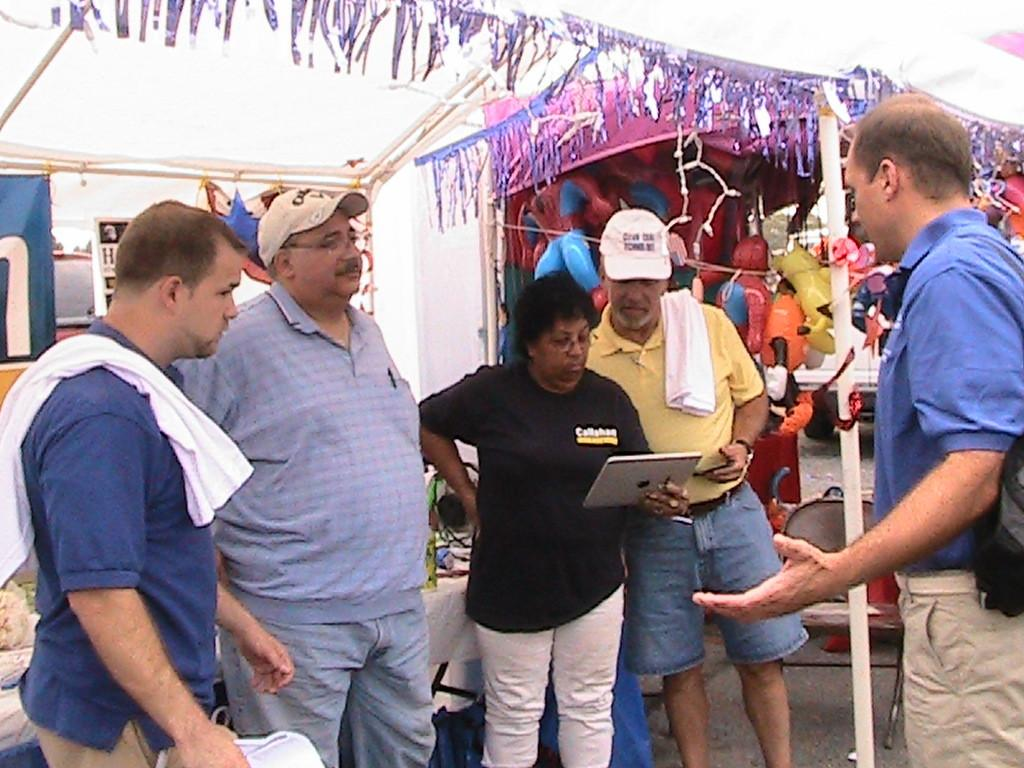How many people are present in the image? There are many people standing in the image. What are some people wearing on their heads? Some people are wearing caps. What is the lady holding in the image? The lady is holding a tab. What can be seen in the background of the image? There are sheds in the background of the image. What is inside the sheds? There are toys inside the sheds. What decorations can be seen in the sheds? There are decorations in the sheds. Where is the hall located in the image? There is no hall present in the image. How many frogs can be seen in the image? There are no frogs present in the image. 